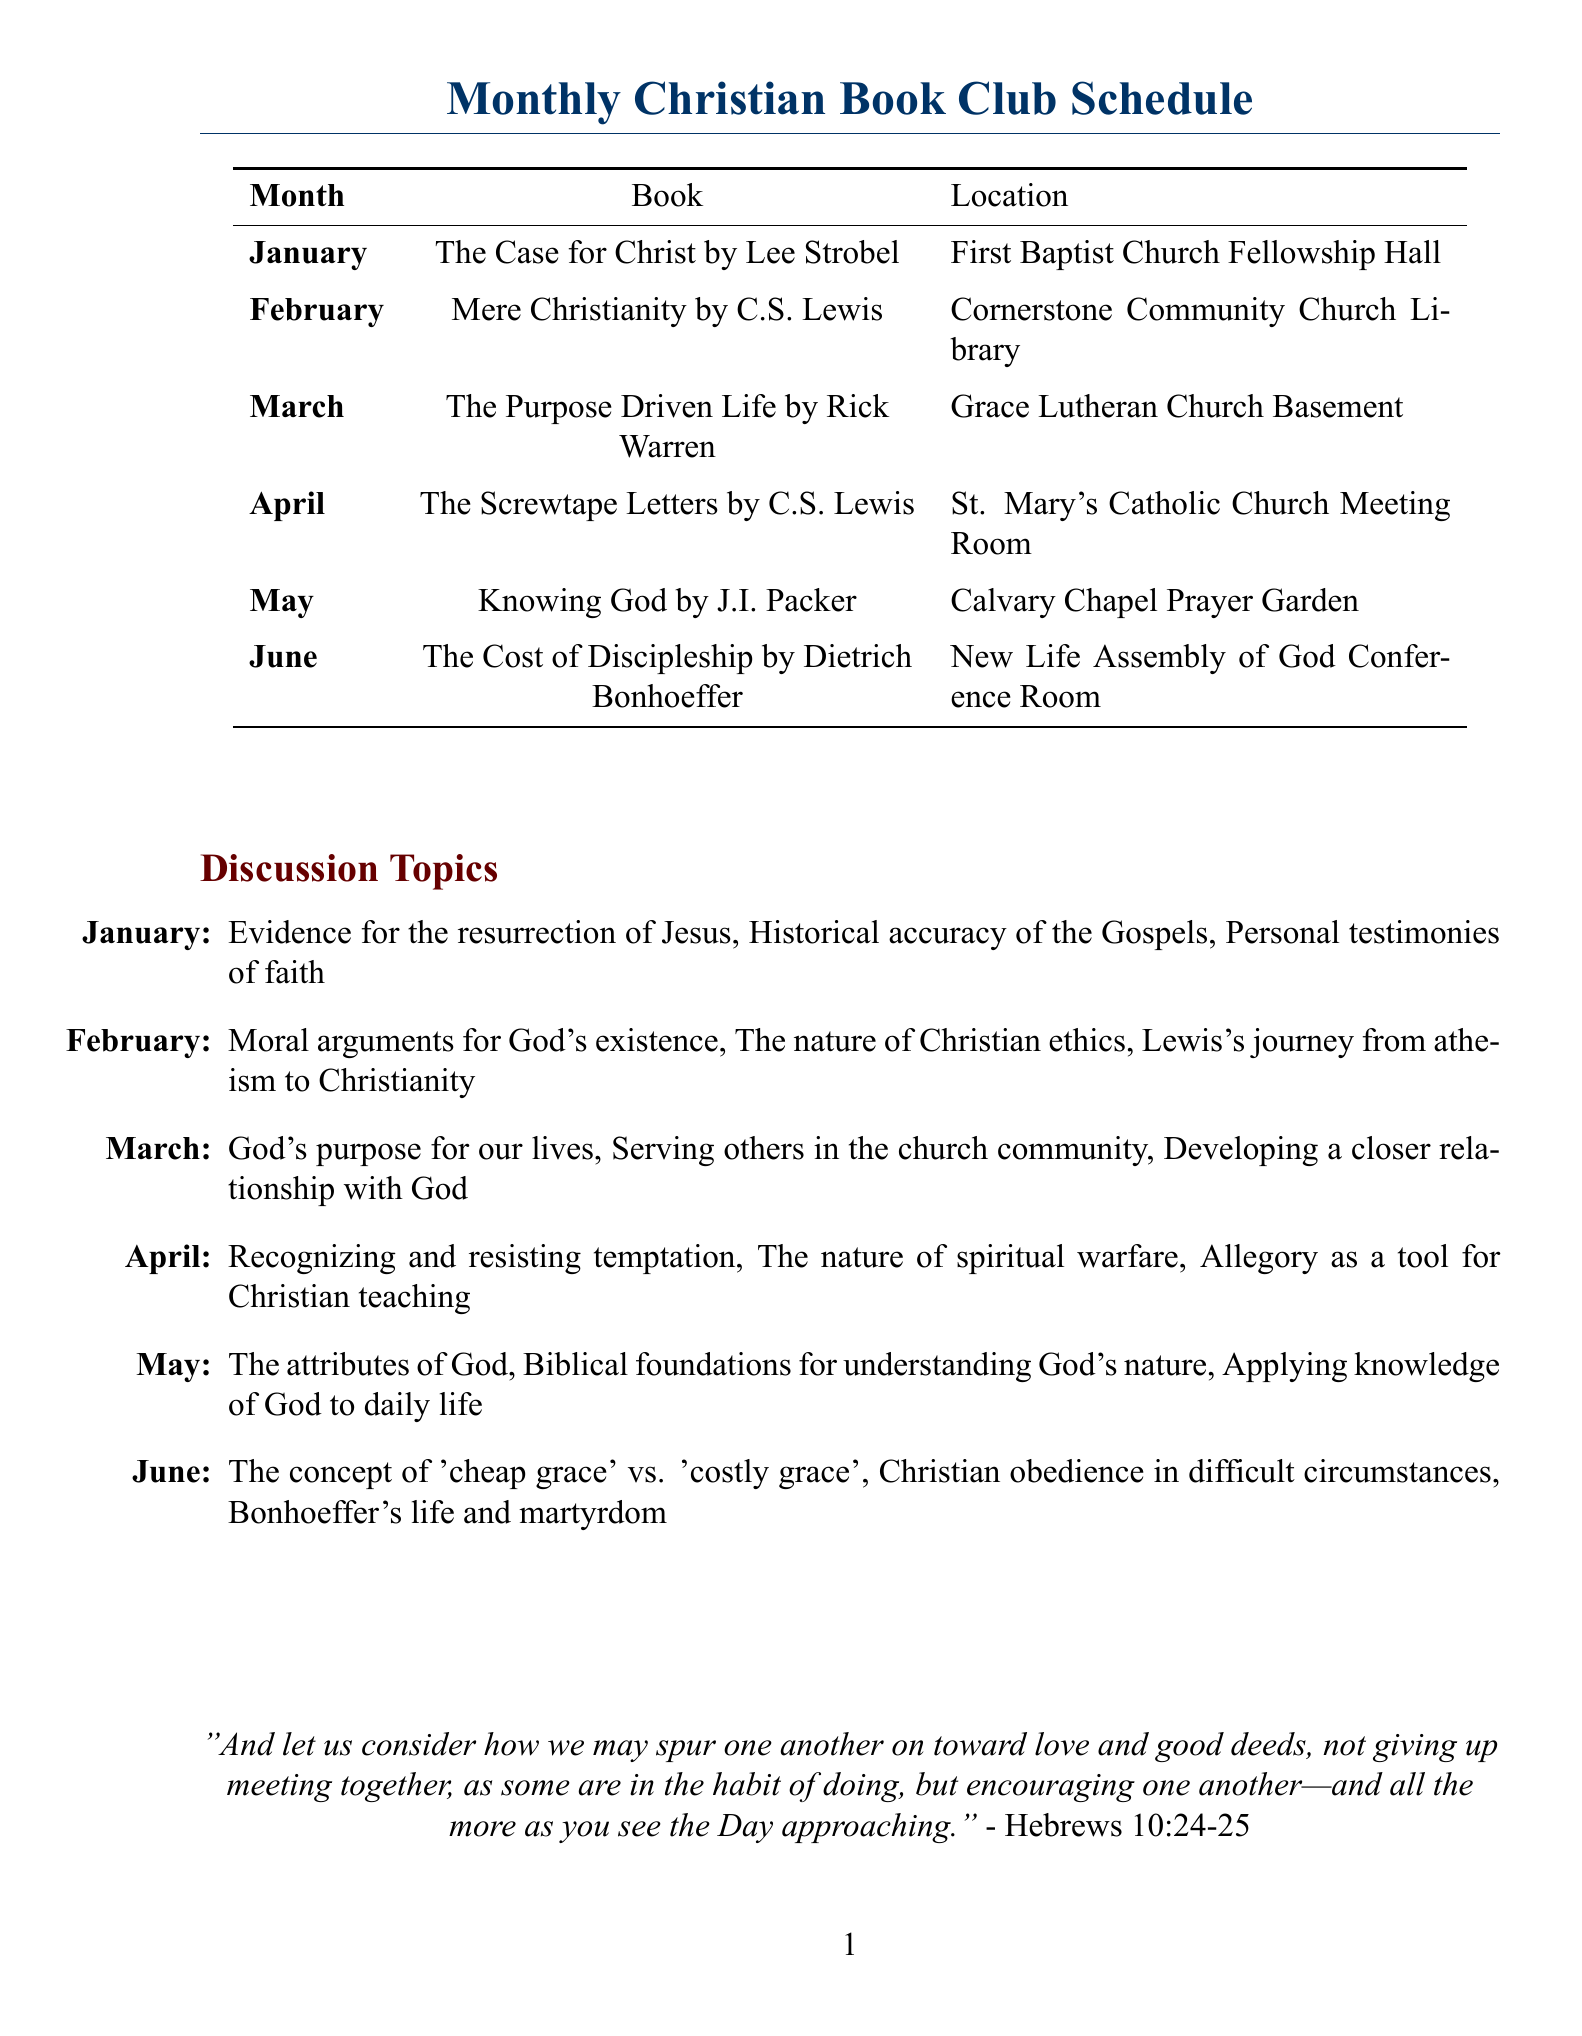What book is discussed in January? The book discussed in January is listed in the schedule.
Answer: The Case for Christ by Lee Strobel Where is the February meeting held? The location for the February meeting is specified in the document.
Answer: Cornerstone Community Church Library What is a discussion topic for March? The document lists the discussion topics under each month, and the March topics include several items.
Answer: God's purpose for our lives How many books are scheduled from January to June? The schedule lists one book for each month from January to June, so the total is easily calculated.
Answer: 6 Which author wrote "The Screwtape Letters"? The author's name is mentioned next to the book in the document.
Answer: C.S. Lewis What is one discussion topic for June? The document details the specific discussion topics for June, which includes multiple points.
Answer: The concept of 'cheap grace' vs. 'costly grace' Where does the May meeting take place? The meeting location for May is provided in the document.
Answer: Calvary Chapel Prayer Garden What is the title of the book for April? The schedule specifies the title of the book for each month, including April.
Answer: The Screwtape Letters by C.S. Lewis 